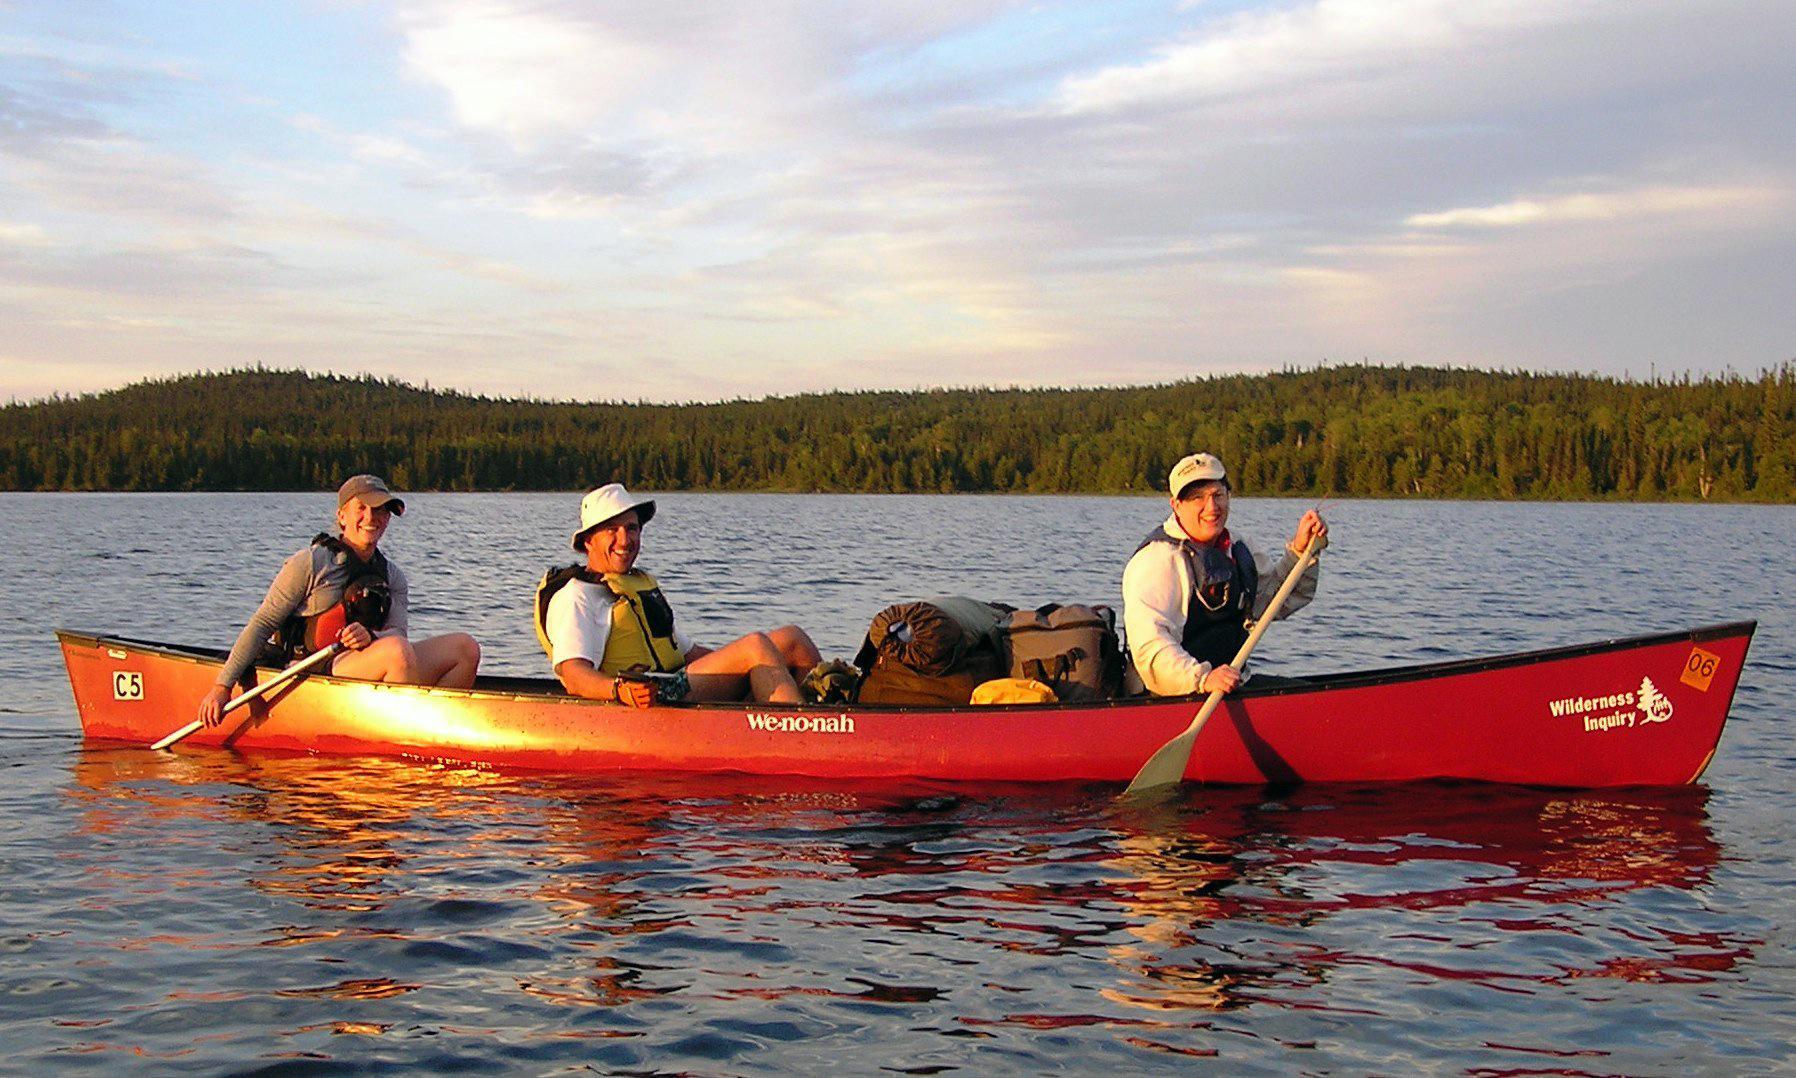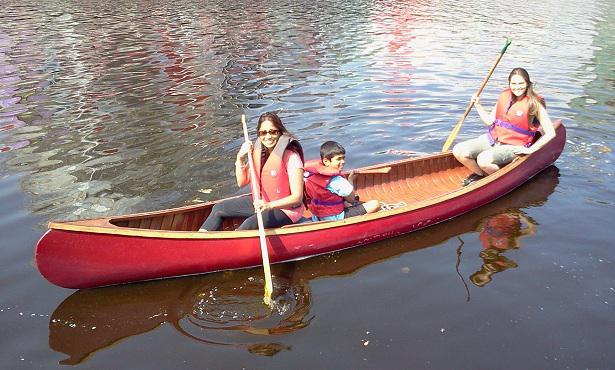The first image is the image on the left, the second image is the image on the right. Analyze the images presented: Is the assertion "In each picture on the right, there are 3 people in a red canoe." valid? Answer yes or no. Yes. 